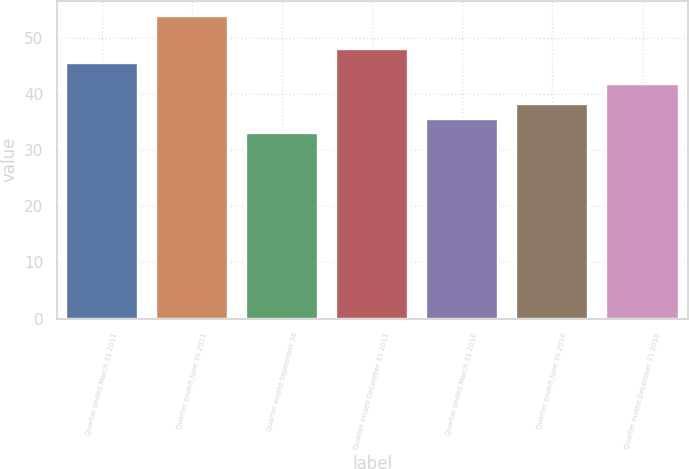Convert chart to OTSL. <chart><loc_0><loc_0><loc_500><loc_500><bar_chart><fcel>Quarter ended March 31 2011<fcel>Quarter ended June 30 2011<fcel>Quarter ended September 30<fcel>Quarter ended December 31 2011<fcel>Quarter ended March 31 2010<fcel>Quarter ended June 30 2010<fcel>Quarter ended December 31 2010<nl><fcel>45.42<fcel>53.88<fcel>33<fcel>47.99<fcel>35.57<fcel>38.14<fcel>41.74<nl></chart> 